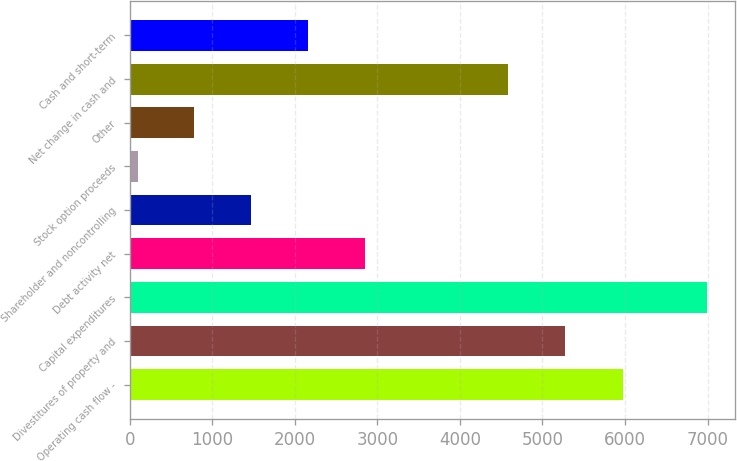Convert chart to OTSL. <chart><loc_0><loc_0><loc_500><loc_500><bar_chart><fcel>Operating cash flow -<fcel>Divestitures of property and<fcel>Capital expenditures<fcel>Debt activity net<fcel>Shareholder and noncontrolling<fcel>Stock option proceeds<fcel>Other<fcel>Net change in cash and<fcel>Cash and short-term<nl><fcel>5981<fcel>5275.5<fcel>6988<fcel>2851<fcel>1472<fcel>93<fcel>782.5<fcel>4586<fcel>2161.5<nl></chart> 